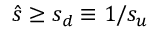Convert formula to latex. <formula><loc_0><loc_0><loc_500><loc_500>\hat { s } \geq s _ { d } \equiv 1 / s _ { u }</formula> 